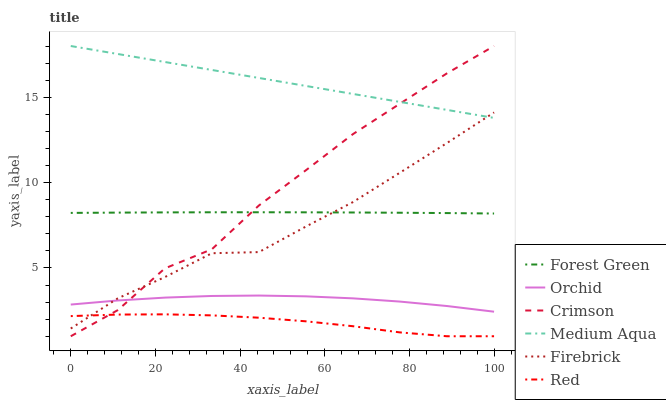Does Red have the minimum area under the curve?
Answer yes or no. Yes. Does Medium Aqua have the maximum area under the curve?
Answer yes or no. Yes. Does Forest Green have the minimum area under the curve?
Answer yes or no. No. Does Forest Green have the maximum area under the curve?
Answer yes or no. No. Is Medium Aqua the smoothest?
Answer yes or no. Yes. Is Crimson the roughest?
Answer yes or no. Yes. Is Forest Green the smoothest?
Answer yes or no. No. Is Forest Green the roughest?
Answer yes or no. No. Does Crimson have the lowest value?
Answer yes or no. Yes. Does Forest Green have the lowest value?
Answer yes or no. No. Does Crimson have the highest value?
Answer yes or no. Yes. Does Forest Green have the highest value?
Answer yes or no. No. Is Orchid less than Forest Green?
Answer yes or no. Yes. Is Medium Aqua greater than Orchid?
Answer yes or no. Yes. Does Orchid intersect Crimson?
Answer yes or no. Yes. Is Orchid less than Crimson?
Answer yes or no. No. Is Orchid greater than Crimson?
Answer yes or no. No. Does Orchid intersect Forest Green?
Answer yes or no. No. 